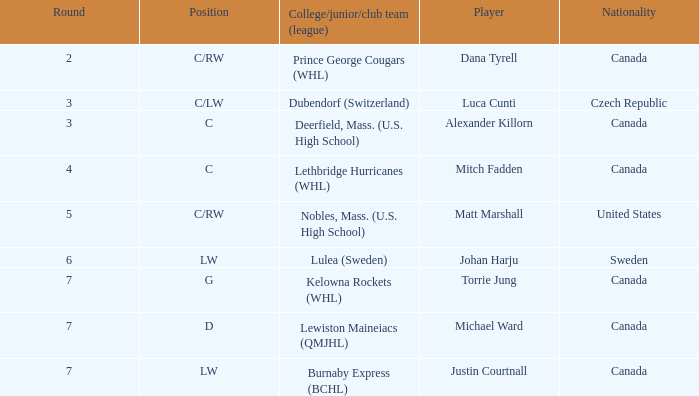What College/junior/club team (league) did mitch fadden play for? Lethbridge Hurricanes (WHL). 